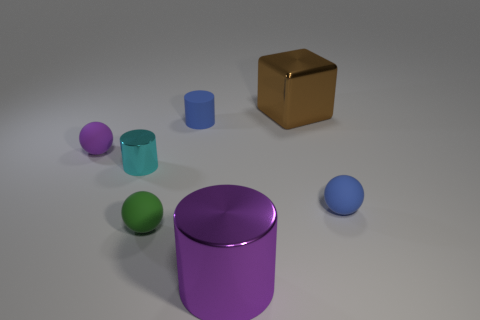Add 1 cubes. How many objects exist? 8 Subtract all spheres. How many objects are left? 4 Subtract all cyan things. Subtract all shiny cylinders. How many objects are left? 4 Add 3 big cubes. How many big cubes are left? 4 Add 6 big blocks. How many big blocks exist? 7 Subtract 0 green cylinders. How many objects are left? 7 